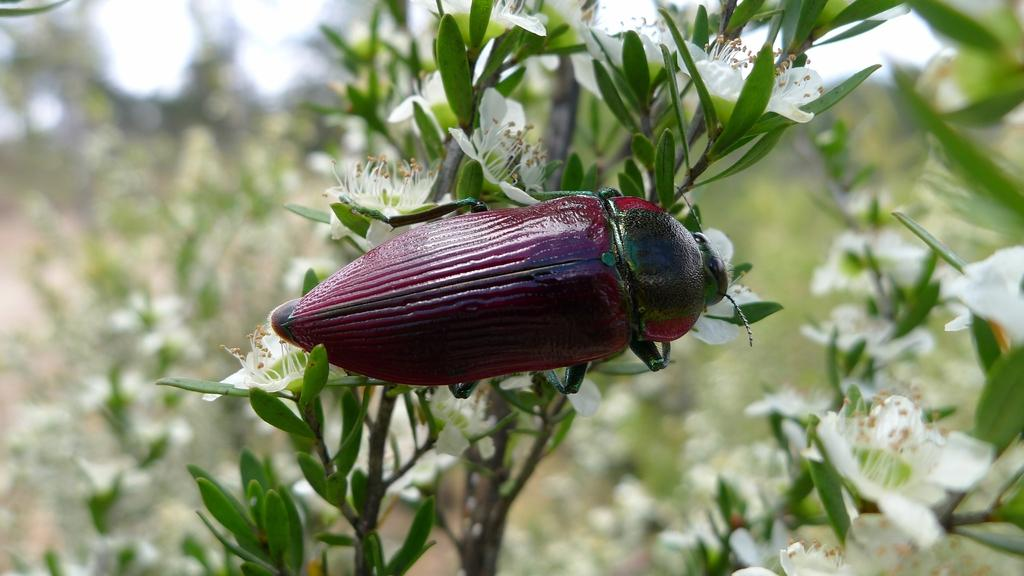What types of living organisms can be seen in the foreground of the picture? Plants and flowers can be seen in the foreground of the picture. Are there any animals visible in the foreground of the picture? Yes, there is an insect in the foreground of the picture. How would you describe the background of the image? The background of the image is blurred. What types of living organisms can be seen in the background of the picture? Plants and flowers can be seen in the background of the picture. What type of jail can be seen in the background of the image? There is no jail present in the image; it features plants, flowers, and an insect in the foreground, with a blurred background. What is your opinion on the behavior of the insect in the image? The image does not provide any information about the behavior of the insect, so it is impossible to form an opinion based on the image alone. 